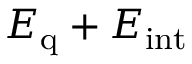<formula> <loc_0><loc_0><loc_500><loc_500>E _ { q } + E _ { i n t }</formula> 